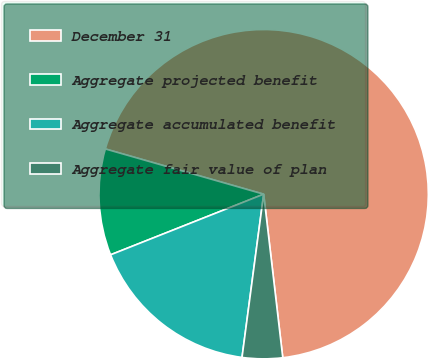<chart> <loc_0><loc_0><loc_500><loc_500><pie_chart><fcel>December 31<fcel>Aggregate projected benefit<fcel>Aggregate accumulated benefit<fcel>Aggregate fair value of plan<nl><fcel>68.72%<fcel>10.43%<fcel>16.9%<fcel>3.95%<nl></chart> 